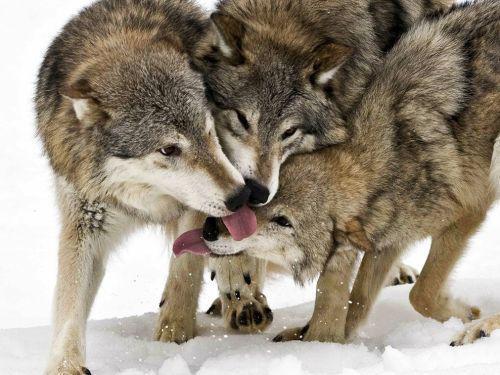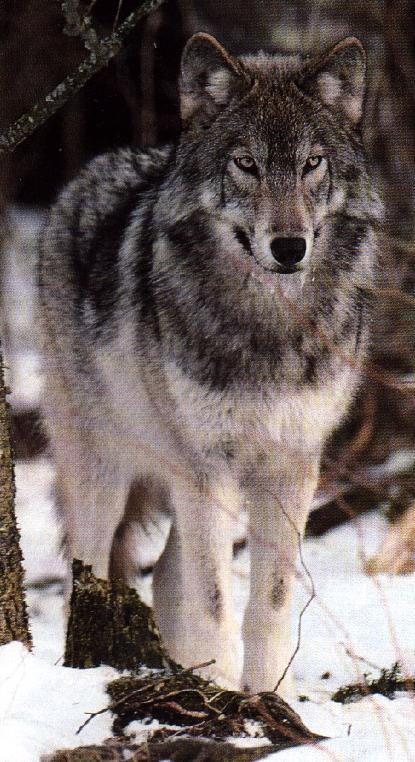The first image is the image on the left, the second image is the image on the right. Given the left and right images, does the statement "Two animals have their tongues out." hold true? Answer yes or no. Yes. The first image is the image on the left, the second image is the image on the right. Evaluate the accuracy of this statement regarding the images: "The left image shows a single adult, wolf with one front paw off the ground and its head somewhat lowered and facing forward.". Is it true? Answer yes or no. No. 